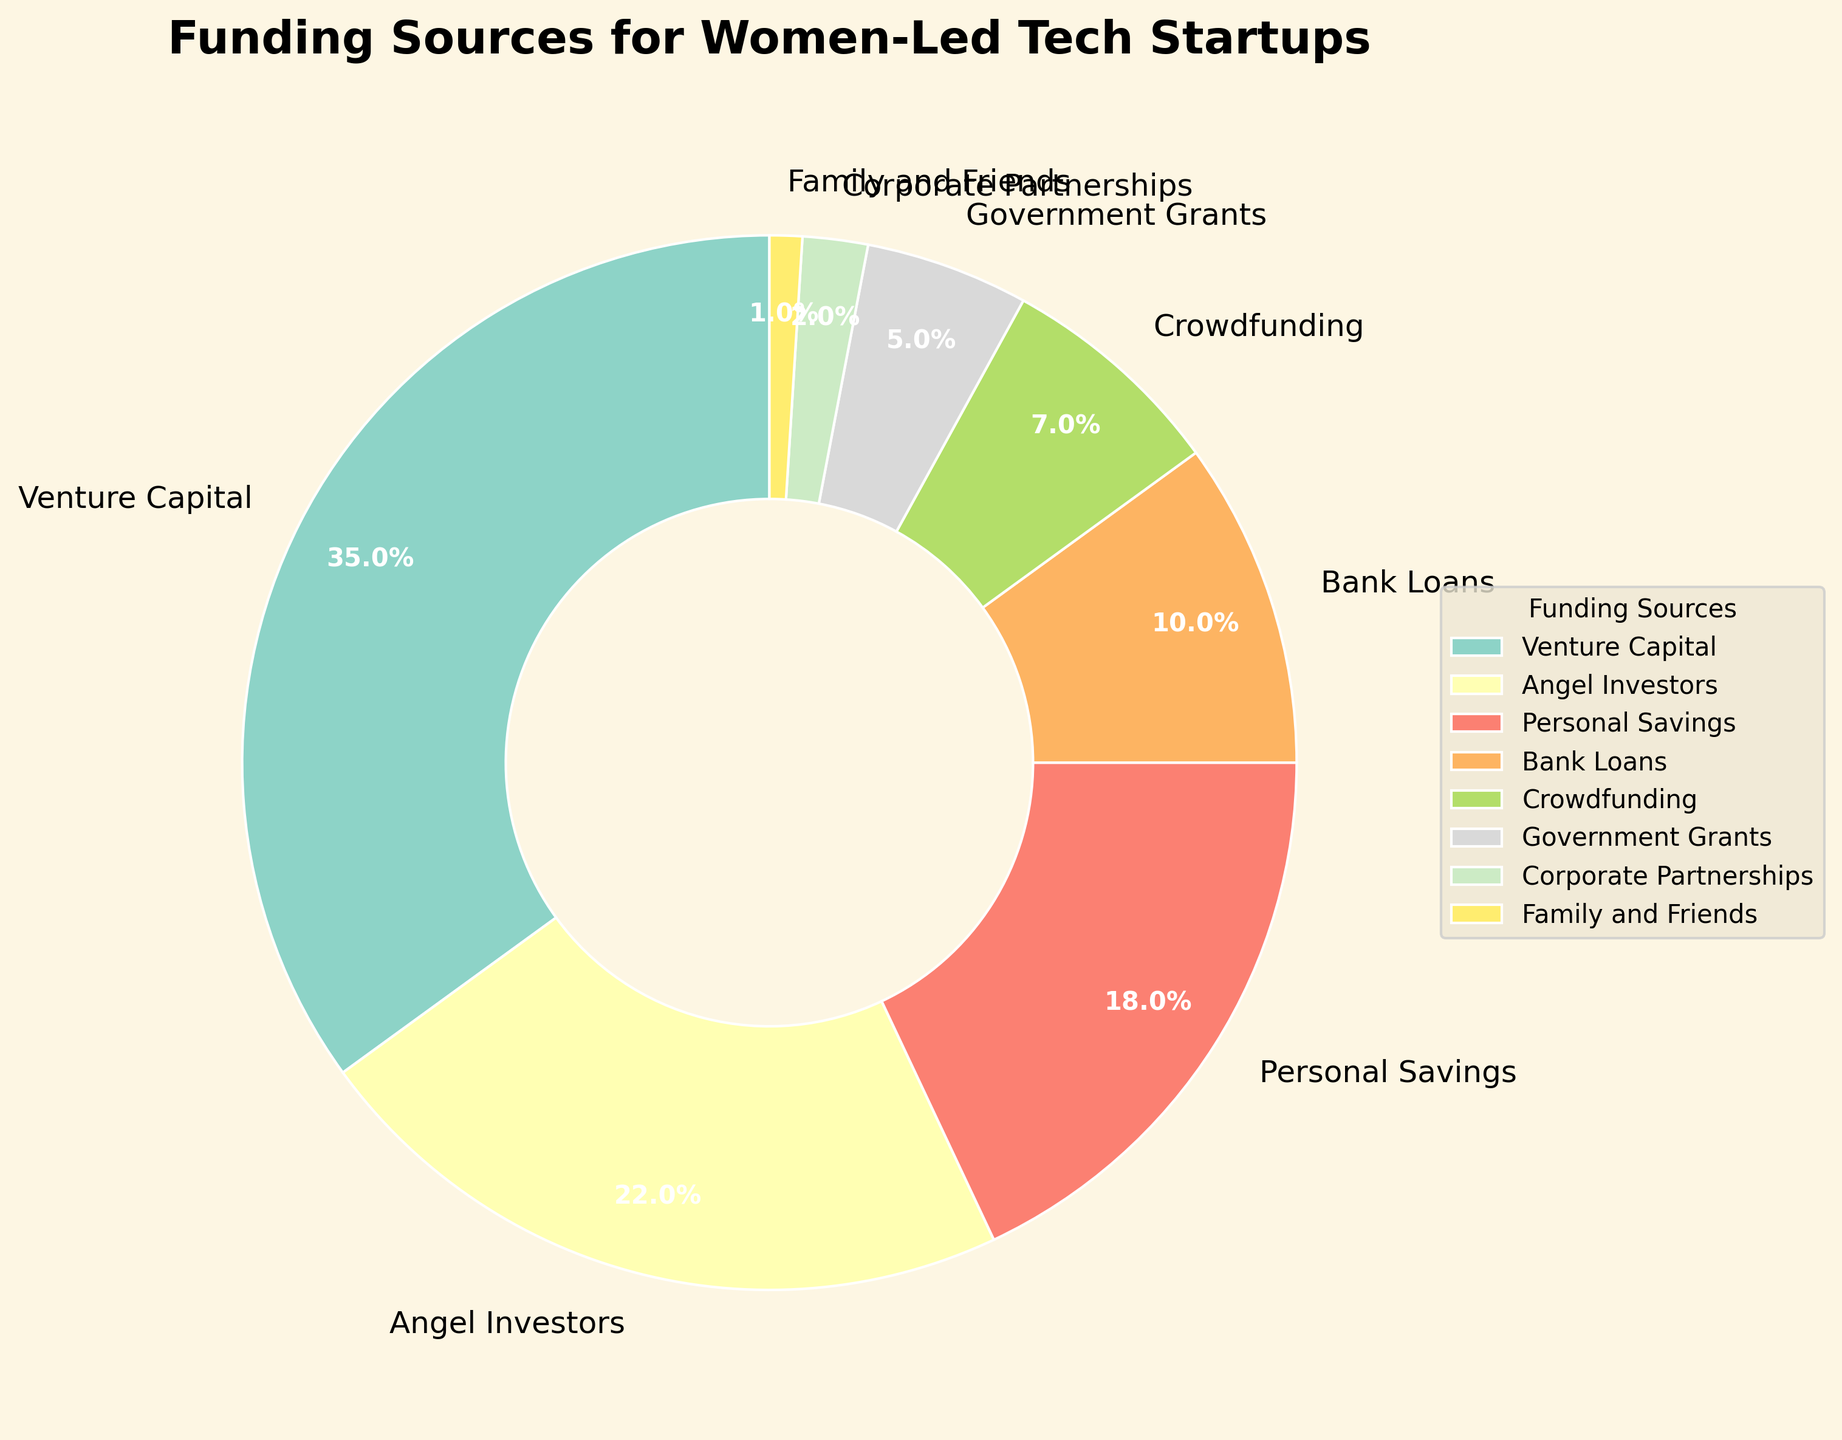Which funding source holds the largest percentage? By looking at the wedges of the pie chart, the wedge labeled "Venture Capital" is the largest. The chart also shows the percentage next to it as 35%.
Answer: Venture Capital What is the combined percentage of Angel Investors and Personal Savings? The pie chart labels Angel Investors with 22% and Personal Savings with 18%. Adding them together gives 22% + 18% = 40%.
Answer: 40% How does the percentage of Bank Loans compare to Government Grants? The pie chart shows Bank Loans at 10% and Government Grants at 5%. Therefore, Bank Loans have a higher percentage.
Answer: Higher Which funding source is depicted in the darkest color? The pie chart visually represents different funding sources using a range of colors. The darkest-colored wedge represents Family and Friends.
Answer: Family and Friends What is the difference in percentage between Crowdfunding and Corporate Partnerships? The pie chart shows Crowdfunding at 7% and Corporate Partnerships at 2%. The difference is 7% - 2% = 5%.
Answer: 5% What are the top three funding sources for women-led tech startups? By looking at the chart, we can see the top three wedges with the highest percentages: Venture Capital (35%), Angel Investors (22%), and Personal Savings (18%).
Answer: Venture Capital, Angel Investors, Personal Savings What is the total percentage of funding coming from external sources (excluding Personal Savings and Family and Friends)? External sources are Venture Capital (35%), Angel Investors (22%), Bank Loans (10%), Crowdfunding (7%), Government Grants (5%), and Corporate Partnerships (2%). Summing these gives 35% + 22% + 10% + 7% + 5% + 2% = 81%.
Answer: 81% Which funding source contributes the least to women-led tech startups? The smallest wedge in the pie chart is labeled Family and Friends, which has 1%.
Answer: Family and Friends What is the average percentage contribution of Venture Capital, Angel Investors, and Personal Savings? The pie chart shows Venture Capital at 35%, Angel Investors at 22%, and Personal Savings at 18%. The average percentage is calculated as (35% + 22% + 18%) / 3 = 75% / 3 = 25%.
Answer: 25% What is the ratio of the contribution from Venture Capital to Government Grants? The pie chart shows Venture Capital at 35% and Government Grants at 5%. The ratio is 35% / 5% = 7:1.
Answer: 7:1 